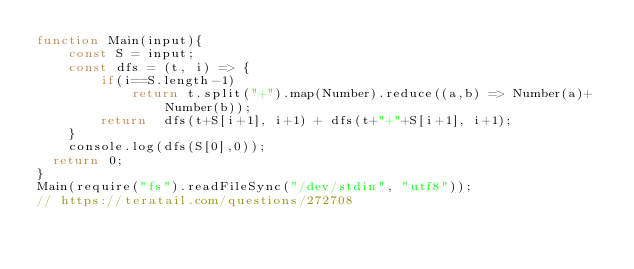Convert code to text. <code><loc_0><loc_0><loc_500><loc_500><_JavaScript_>function Main(input){
    const S = input;
    const dfs = (t, i) => {
        if(i==S.length-1)
            return t.split("+").map(Number).reduce((a,b) => Number(a)+Number(b));
        return  dfs(t+S[i+1], i+1) + dfs(t+"+"+S[i+1], i+1);
    }
    console.log(dfs(S[0],0));
  return 0;
}
Main(require("fs").readFileSync("/dev/stdin", "utf8"));
// https://teratail.com/questions/272708
</code> 